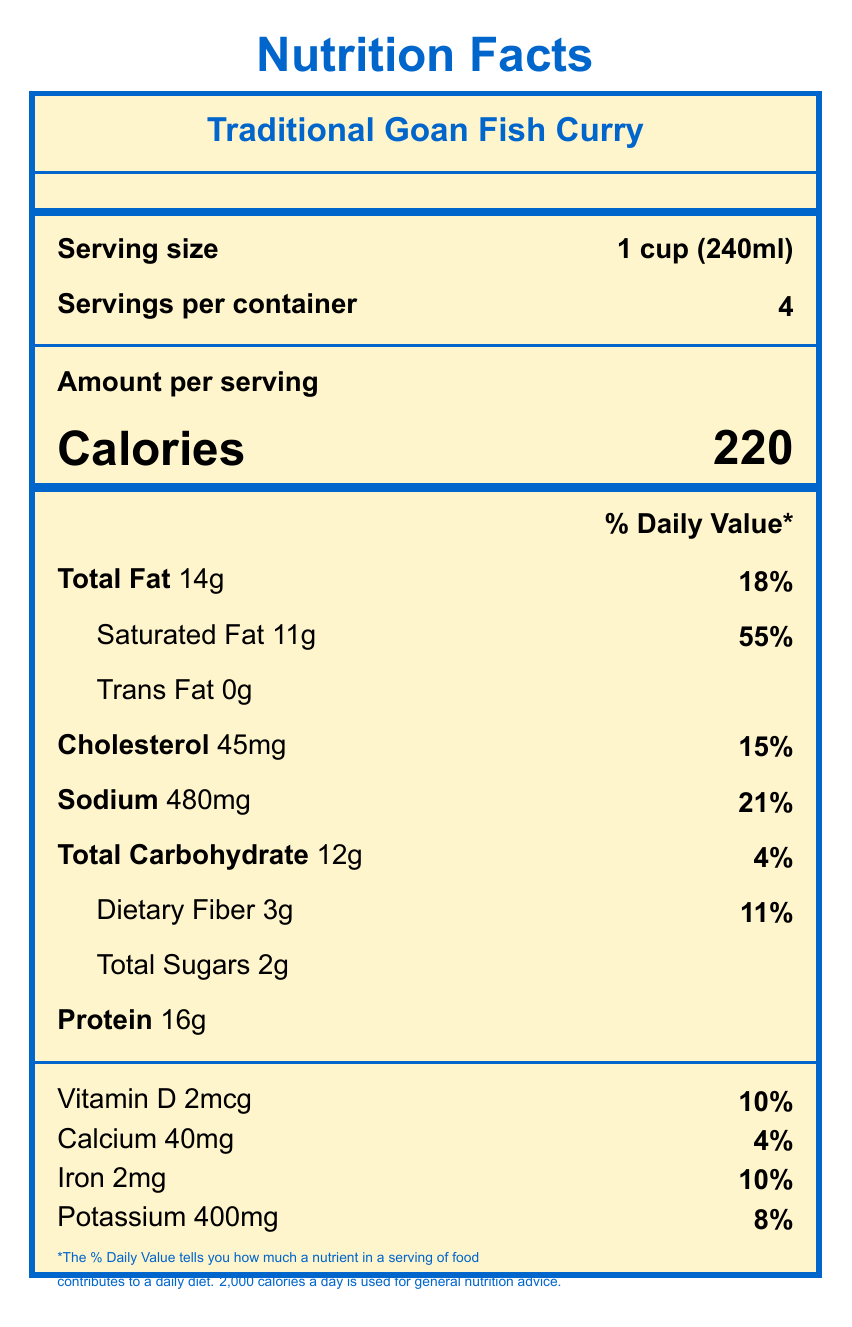what is the serving size? The serving size is clearly mentioned as "1 cup (240ml)" under the "Serving size" label near the top of the document.
Answer: 1 cup (240ml) how many servings are there per container? The number of servings per container is specified on the document as "Servings per container" with the value 4.
Answer: 4 how many calories are in one serving of the Traditional Goan Fish Curry? The amount of calories per serving is shown as 220 under the "Calories" label.
Answer: 220 what is the total fat content per serving? The total fat content per serving is listed as 14g under the "Total Fat" label.
Answer: 14g what percentage of the daily value of saturated fat does one serving provide? The percentage of the daily value for saturated fat is indicated as 55% next to the "Saturated Fat" amount.
Answer: 55% how much protein does one serving of Traditional Goan Fish Curry contain? A. 14g B. 16g C. 12g D. 18g The protein content per serving is stated as 16g in the "Protein" section.
Answer: B which nutrient has the highest % daily value in one serving? A. Sodium B. Dietary Fiber C. Saturated Fat D. Vitamin D Saturated fat has the highest % daily value, which is 55%, as shown under the "Saturated Fat" label.
Answer: C does this document provide information about the cholesterol content? The document lists the cholesterol content as "45mg" with a daily value percentage of "15%" under the "Cholesterol" label.
Answer: Yes what is the main idea of the document? The entire document focuses on the nutritional facts of the Traditional Goan Fish Curry, including how much of each key nutrient a serving provides and its cultural significance.
Answer: The document provides nutritional information for Traditional Goan Fish Curry, detailing the serving size, number of servings, calories, and various nutrient contents per serving. how much sodium does one serving of Traditional Goan Fish Curry contain? The sodium content per serving is displayed as 480mg under the "Sodium" label.
Answer: 480mg how much calcium is in a single serving? The calcium content in a single serving is mentioned as 40mg under the "Calcium" label.
Answer: 40mg is the serving size specified in milliliters? The serving size is given as "1 cup (240ml)" which includes measurements in milliliters.
Answer: Yes how much dietary fiber does one serving of fish curry provide? The dietary fiber content per serving is listed as 3g under the "Dietary Fiber" label.
Answer: 3g what percentage of the daily value of iron does one serving of fish curry contain? The document shows that one serving contains 10% of the daily value for iron.
Answer: 10% what are the primary sources of omega-3 fatty acids in this fish curry? The information about primary sources of omega-3 fatty acids is not provided in the visual document and hence cannot be determined.
Answer: Cannot be determined 